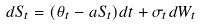<formula> <loc_0><loc_0><loc_500><loc_500>d S _ { t } = ( \theta _ { t } - a S _ { t } ) d t + \sigma _ { t } d W _ { t }</formula> 